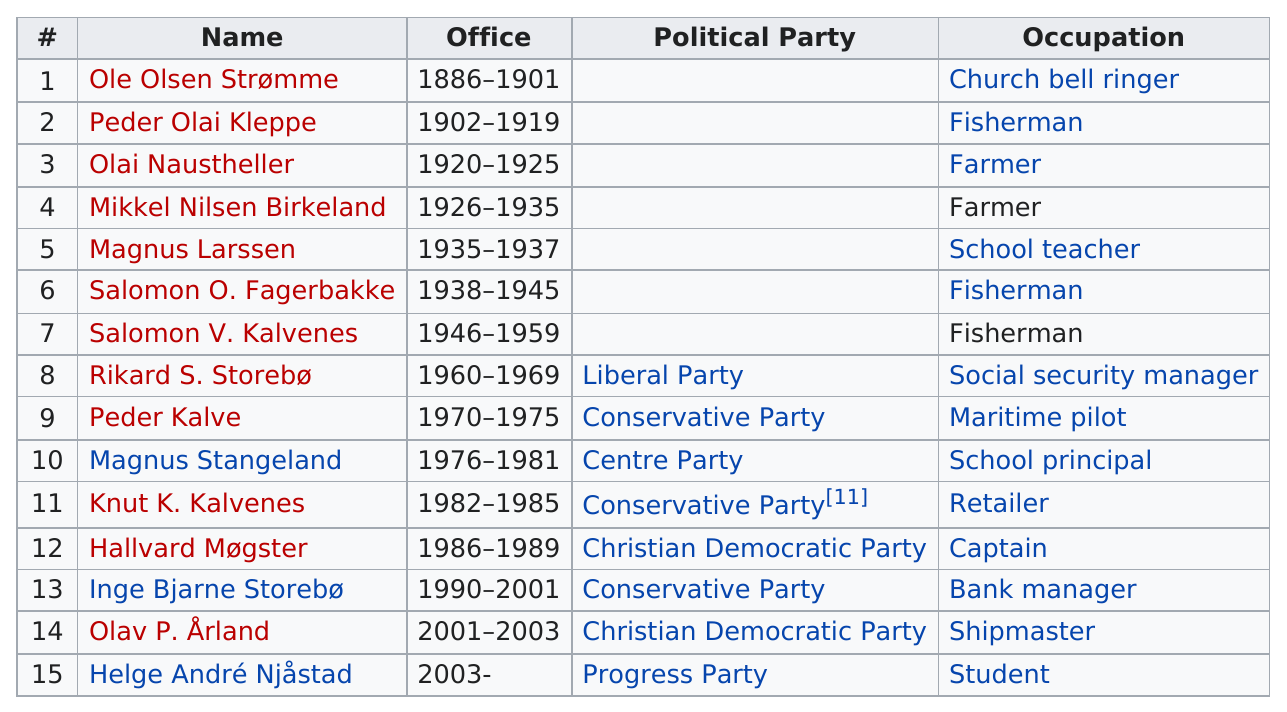Outline some significant characteristics in this image. The Conservative Party has had the most elected mayors. Since 1886, a total of six Austevoll mayors have had maritime-related occupations. Five mayors, either fishermen or farmers. Ole Olsen Strømme was the first mayor of Austevoll. After Peder Kalve, two conservative party mayors were elected. 